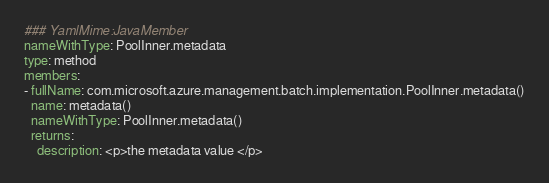<code> <loc_0><loc_0><loc_500><loc_500><_YAML_>### YamlMime:JavaMember
nameWithType: PoolInner.metadata
type: method
members:
- fullName: com.microsoft.azure.management.batch.implementation.PoolInner.metadata()
  name: metadata()
  nameWithType: PoolInner.metadata()
  returns:
    description: <p>the metadata value </p></code> 